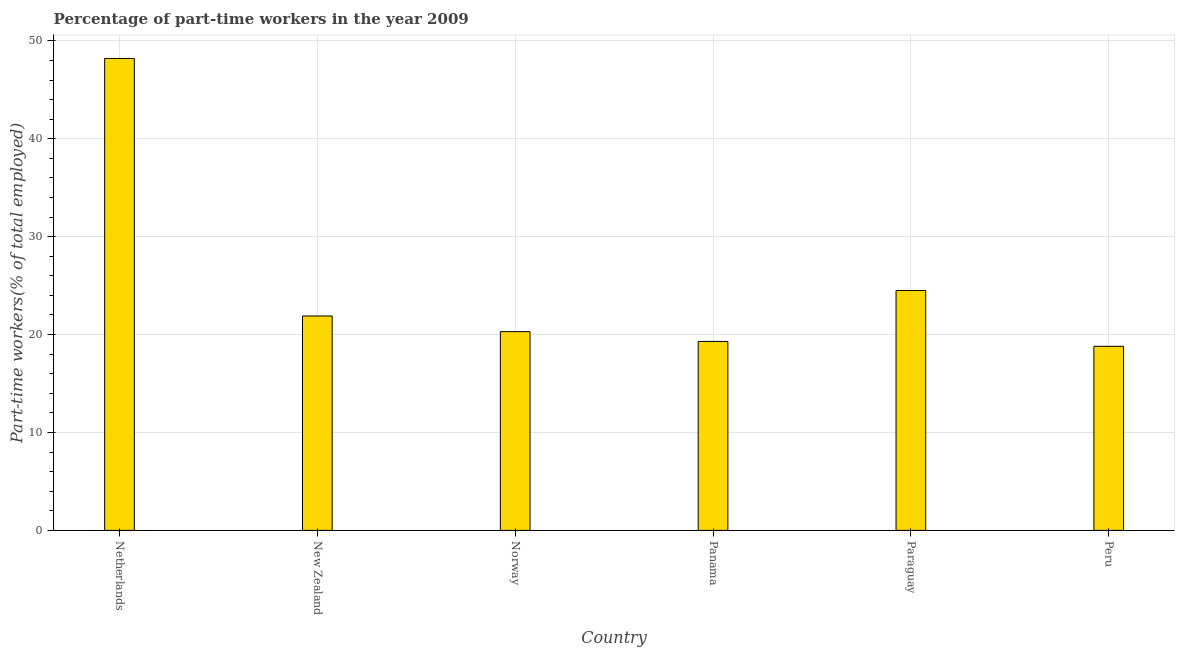Does the graph contain grids?
Your response must be concise. Yes. What is the title of the graph?
Keep it short and to the point. Percentage of part-time workers in the year 2009. What is the label or title of the X-axis?
Your answer should be very brief. Country. What is the label or title of the Y-axis?
Provide a short and direct response. Part-time workers(% of total employed). What is the percentage of part-time workers in Norway?
Offer a very short reply. 20.3. Across all countries, what is the maximum percentage of part-time workers?
Keep it short and to the point. 48.2. Across all countries, what is the minimum percentage of part-time workers?
Keep it short and to the point. 18.8. In which country was the percentage of part-time workers maximum?
Provide a short and direct response. Netherlands. What is the sum of the percentage of part-time workers?
Your answer should be compact. 153. What is the difference between the percentage of part-time workers in New Zealand and Peru?
Your answer should be very brief. 3.1. What is the average percentage of part-time workers per country?
Offer a very short reply. 25.5. What is the median percentage of part-time workers?
Your answer should be compact. 21.1. In how many countries, is the percentage of part-time workers greater than 18 %?
Keep it short and to the point. 6. What is the ratio of the percentage of part-time workers in Norway to that in Peru?
Keep it short and to the point. 1.08. Is the percentage of part-time workers in Netherlands less than that in Peru?
Your answer should be compact. No. Is the difference between the percentage of part-time workers in Norway and Panama greater than the difference between any two countries?
Provide a short and direct response. No. What is the difference between the highest and the second highest percentage of part-time workers?
Give a very brief answer. 23.7. What is the difference between the highest and the lowest percentage of part-time workers?
Provide a short and direct response. 29.4. In how many countries, is the percentage of part-time workers greater than the average percentage of part-time workers taken over all countries?
Your answer should be compact. 1. How many bars are there?
Make the answer very short. 6. Are all the bars in the graph horizontal?
Provide a succinct answer. No. How many countries are there in the graph?
Offer a terse response. 6. What is the Part-time workers(% of total employed) of Netherlands?
Offer a terse response. 48.2. What is the Part-time workers(% of total employed) in New Zealand?
Your answer should be very brief. 21.9. What is the Part-time workers(% of total employed) of Norway?
Your response must be concise. 20.3. What is the Part-time workers(% of total employed) of Panama?
Your answer should be compact. 19.3. What is the Part-time workers(% of total employed) of Paraguay?
Offer a very short reply. 24.5. What is the Part-time workers(% of total employed) in Peru?
Offer a terse response. 18.8. What is the difference between the Part-time workers(% of total employed) in Netherlands and New Zealand?
Your answer should be very brief. 26.3. What is the difference between the Part-time workers(% of total employed) in Netherlands and Norway?
Your answer should be compact. 27.9. What is the difference between the Part-time workers(% of total employed) in Netherlands and Panama?
Give a very brief answer. 28.9. What is the difference between the Part-time workers(% of total employed) in Netherlands and Paraguay?
Your answer should be compact. 23.7. What is the difference between the Part-time workers(% of total employed) in Netherlands and Peru?
Your response must be concise. 29.4. What is the difference between the Part-time workers(% of total employed) in New Zealand and Norway?
Keep it short and to the point. 1.6. What is the difference between the Part-time workers(% of total employed) in New Zealand and Paraguay?
Ensure brevity in your answer.  -2.6. What is the difference between the Part-time workers(% of total employed) in New Zealand and Peru?
Provide a short and direct response. 3.1. What is the difference between the Part-time workers(% of total employed) in Norway and Panama?
Provide a short and direct response. 1. What is the difference between the Part-time workers(% of total employed) in Panama and Paraguay?
Offer a very short reply. -5.2. What is the difference between the Part-time workers(% of total employed) in Panama and Peru?
Ensure brevity in your answer.  0.5. What is the difference between the Part-time workers(% of total employed) in Paraguay and Peru?
Provide a short and direct response. 5.7. What is the ratio of the Part-time workers(% of total employed) in Netherlands to that in New Zealand?
Your answer should be very brief. 2.2. What is the ratio of the Part-time workers(% of total employed) in Netherlands to that in Norway?
Your answer should be very brief. 2.37. What is the ratio of the Part-time workers(% of total employed) in Netherlands to that in Panama?
Provide a succinct answer. 2.5. What is the ratio of the Part-time workers(% of total employed) in Netherlands to that in Paraguay?
Offer a terse response. 1.97. What is the ratio of the Part-time workers(% of total employed) in Netherlands to that in Peru?
Keep it short and to the point. 2.56. What is the ratio of the Part-time workers(% of total employed) in New Zealand to that in Norway?
Keep it short and to the point. 1.08. What is the ratio of the Part-time workers(% of total employed) in New Zealand to that in Panama?
Your answer should be compact. 1.14. What is the ratio of the Part-time workers(% of total employed) in New Zealand to that in Paraguay?
Keep it short and to the point. 0.89. What is the ratio of the Part-time workers(% of total employed) in New Zealand to that in Peru?
Offer a very short reply. 1.17. What is the ratio of the Part-time workers(% of total employed) in Norway to that in Panama?
Provide a short and direct response. 1.05. What is the ratio of the Part-time workers(% of total employed) in Norway to that in Paraguay?
Make the answer very short. 0.83. What is the ratio of the Part-time workers(% of total employed) in Norway to that in Peru?
Make the answer very short. 1.08. What is the ratio of the Part-time workers(% of total employed) in Panama to that in Paraguay?
Provide a succinct answer. 0.79. What is the ratio of the Part-time workers(% of total employed) in Panama to that in Peru?
Give a very brief answer. 1.03. What is the ratio of the Part-time workers(% of total employed) in Paraguay to that in Peru?
Keep it short and to the point. 1.3. 